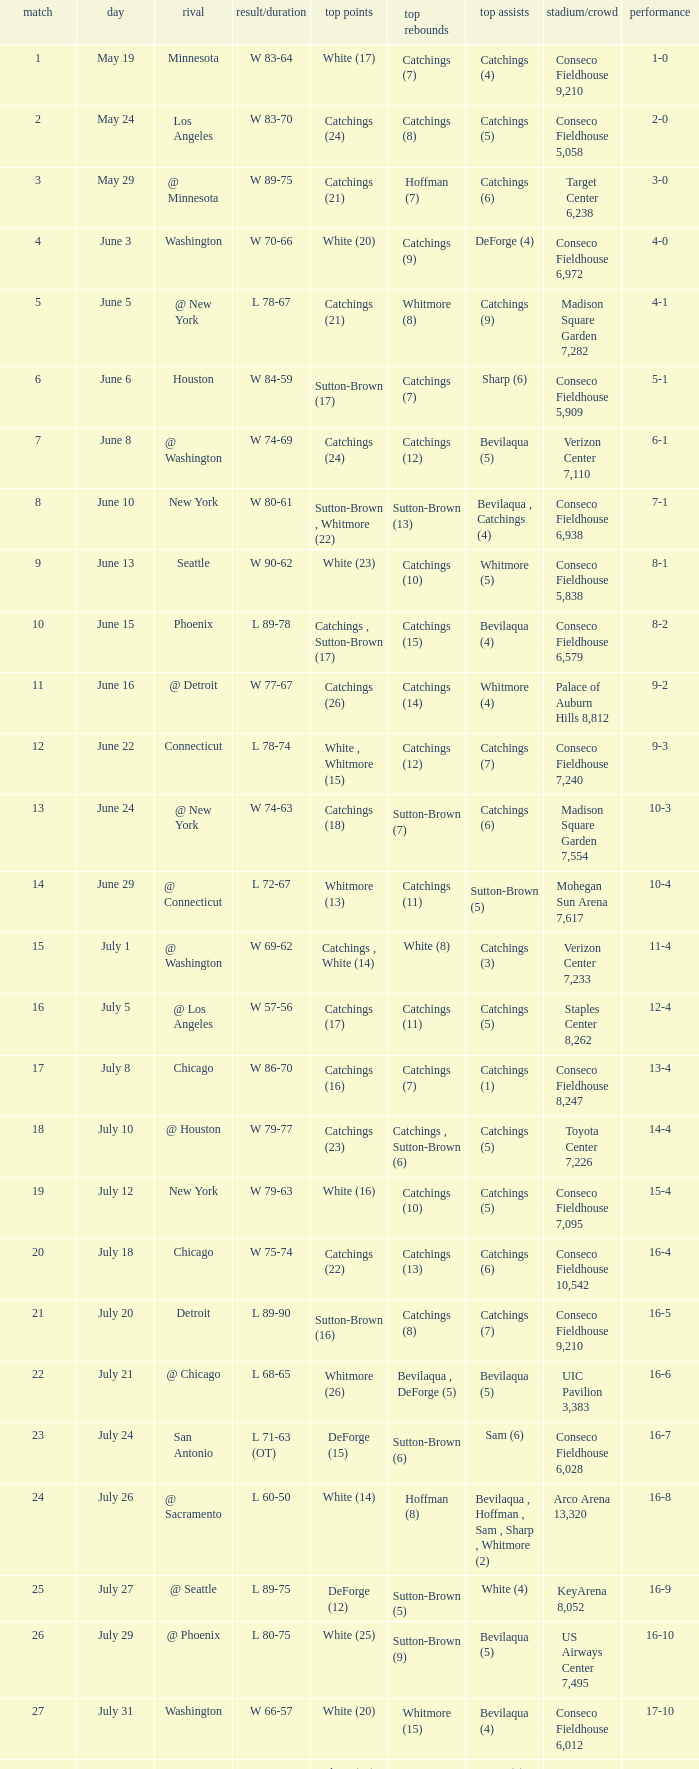Name the date where score time is w 74-63 June 24. 